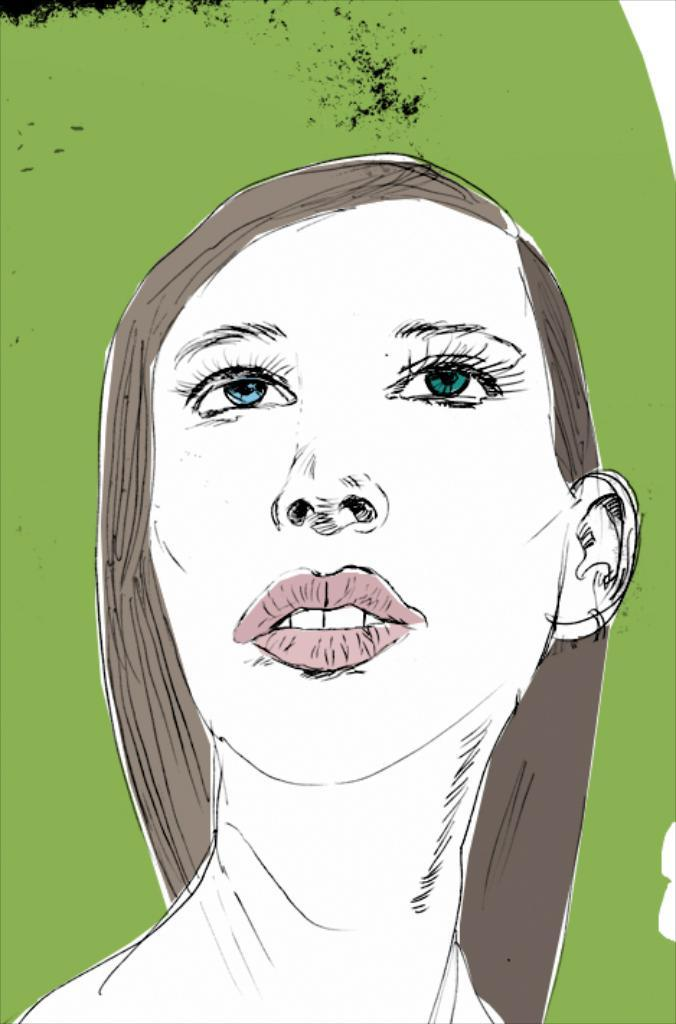What is the main subject of the picture? The main subject of the picture is a sketch. What does the sketch depict? The sketch depicts the face of a person. What date is circled on the calendar in the image? There is no calendar present in the image, so it is not possible to answer that question. 